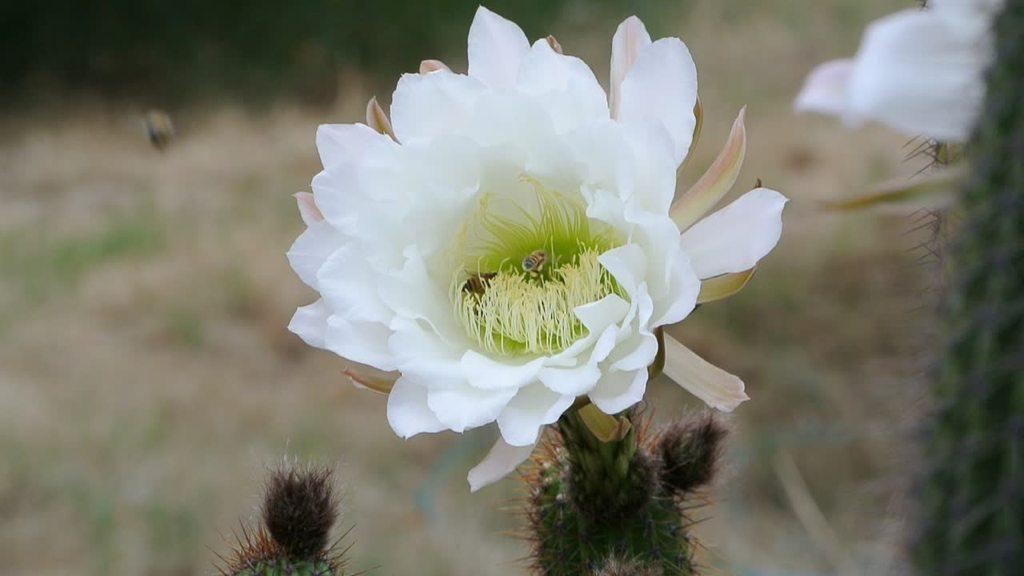What is the main subject of the image? There is a flower in the center of the image. Can you describe the colors of the flower? The flower has green and white colors. Are there any other flowers visible in the image? Yes, there is another white color flower in the top left corner of the image. What is the level of anger displayed by the flower in the image? There is no indication of anger in the image, as flowers do not have emotions. 